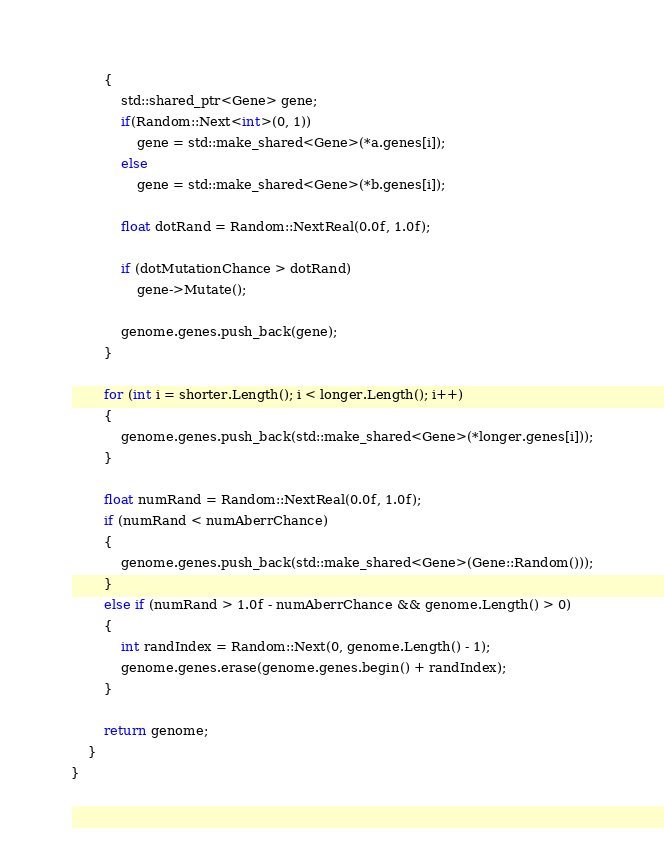Convert code to text. <code><loc_0><loc_0><loc_500><loc_500><_C++_>		{
			std::shared_ptr<Gene> gene;
			if(Random::Next<int>(0, 1))
				gene = std::make_shared<Gene>(*a.genes[i]);
			else
				gene = std::make_shared<Gene>(*b.genes[i]);

			float dotRand = Random::NextReal(0.0f, 1.0f);

			if (dotMutationChance > dotRand)
				gene->Mutate();

			genome.genes.push_back(gene);
		}

		for (int i = shorter.Length(); i < longer.Length(); i++)
		{
			genome.genes.push_back(std::make_shared<Gene>(*longer.genes[i]));
		}

		float numRand = Random::NextReal(0.0f, 1.0f);
		if (numRand < numAberrChance)
		{
			genome.genes.push_back(std::make_shared<Gene>(Gene::Random()));
		}
		else if (numRand > 1.0f - numAberrChance && genome.Length() > 0)
		{
			int randIndex = Random::Next(0, genome.Length() - 1);
			genome.genes.erase(genome.genes.begin() + randIndex);
		}

		return genome;
	}
}</code> 